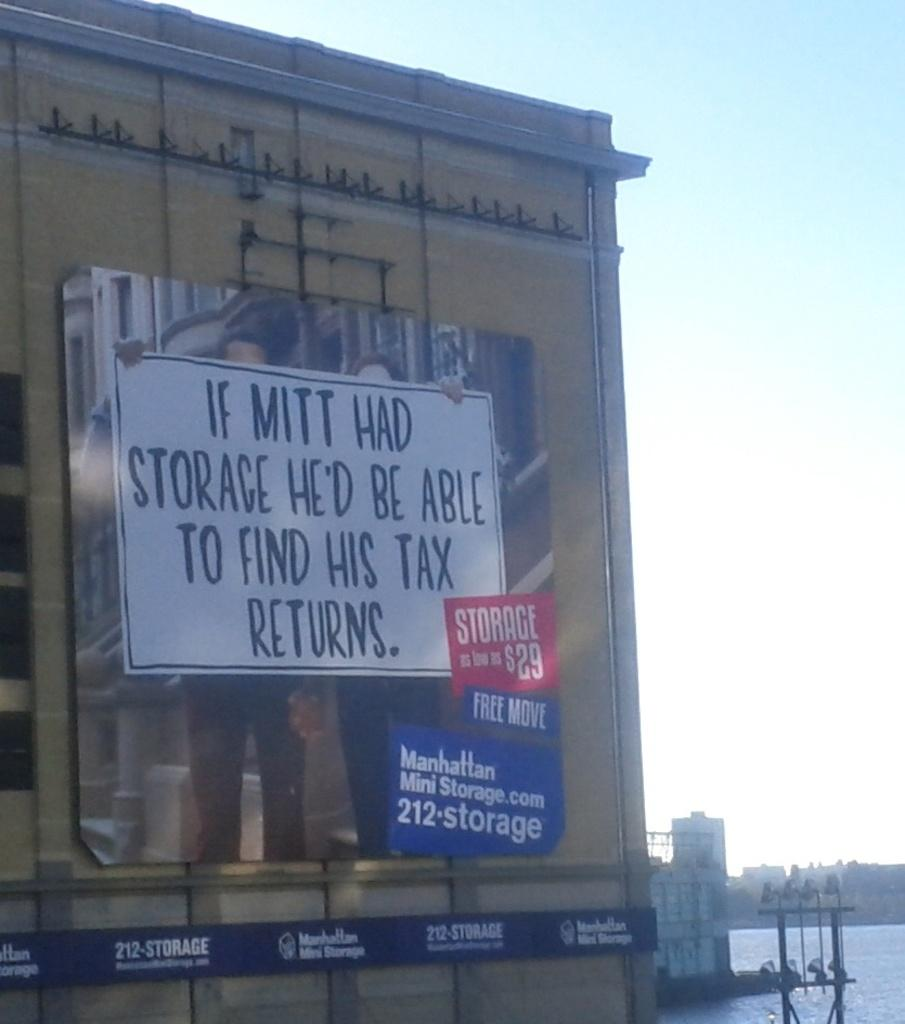<image>
Offer a succinct explanation of the picture presented. A storage advertisement claiming that if Mitt had storage he would be able to find his tax returns. 